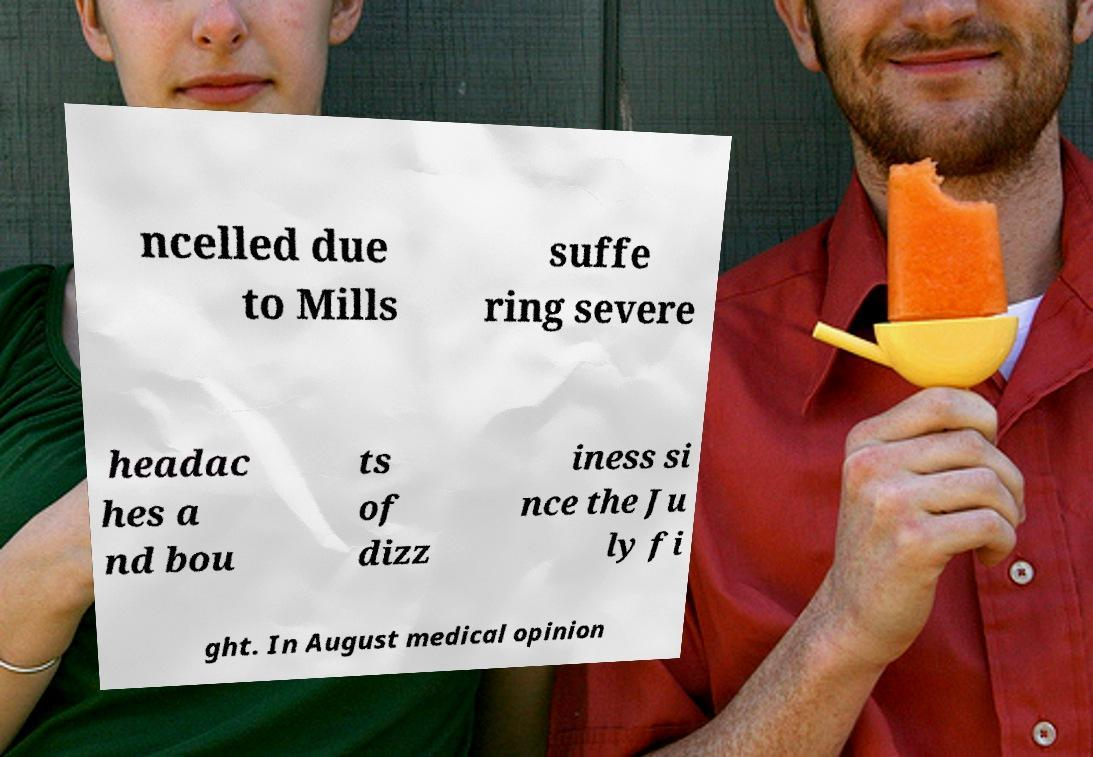What messages or text are displayed in this image? I need them in a readable, typed format. ncelled due to Mills suffe ring severe headac hes a nd bou ts of dizz iness si nce the Ju ly fi ght. In August medical opinion 